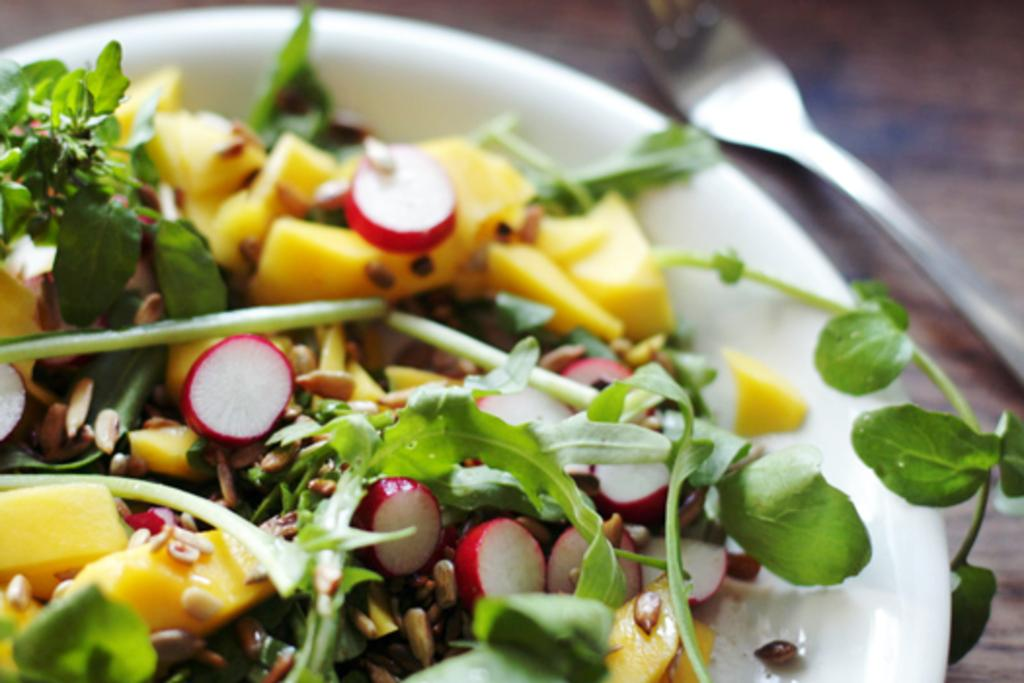What piece of furniture is present in the image? There is a table in the image. What is placed on the table? There is a plate on the table. What is on the plate? The plate contains food. What utensil is present on the table? There is a fork on the table. What type of wealth can be seen in the image? There is no indication of wealth in the image; it features a table with a plate, food, and a fork. Can you tell me how many rooms are visible in the image? There is no room visible in the image; it is focused on a table with a plate, food, and a fork. 